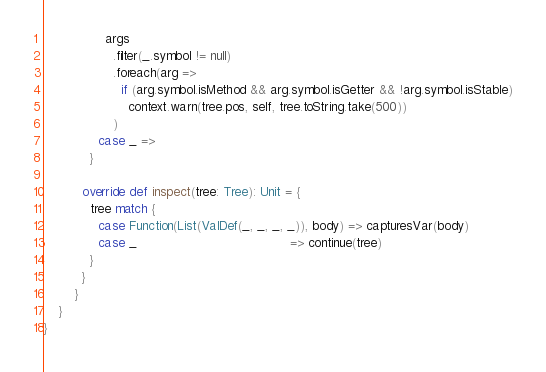<code> <loc_0><loc_0><loc_500><loc_500><_Scala_>                args
                  .filter(_.symbol != null)
                  .foreach(arg =>
                    if (arg.symbol.isMethod && arg.symbol.isGetter && !arg.symbol.isStable)
                      context.warn(tree.pos, self, tree.toString.take(500))
                  )
              case _ =>
            }

          override def inspect(tree: Tree): Unit = {
            tree match {
              case Function(List(ValDef(_, _, _, _)), body) => capturesVar(body)
              case _                                        => continue(tree)
            }
          }
        }
    }
}
</code> 